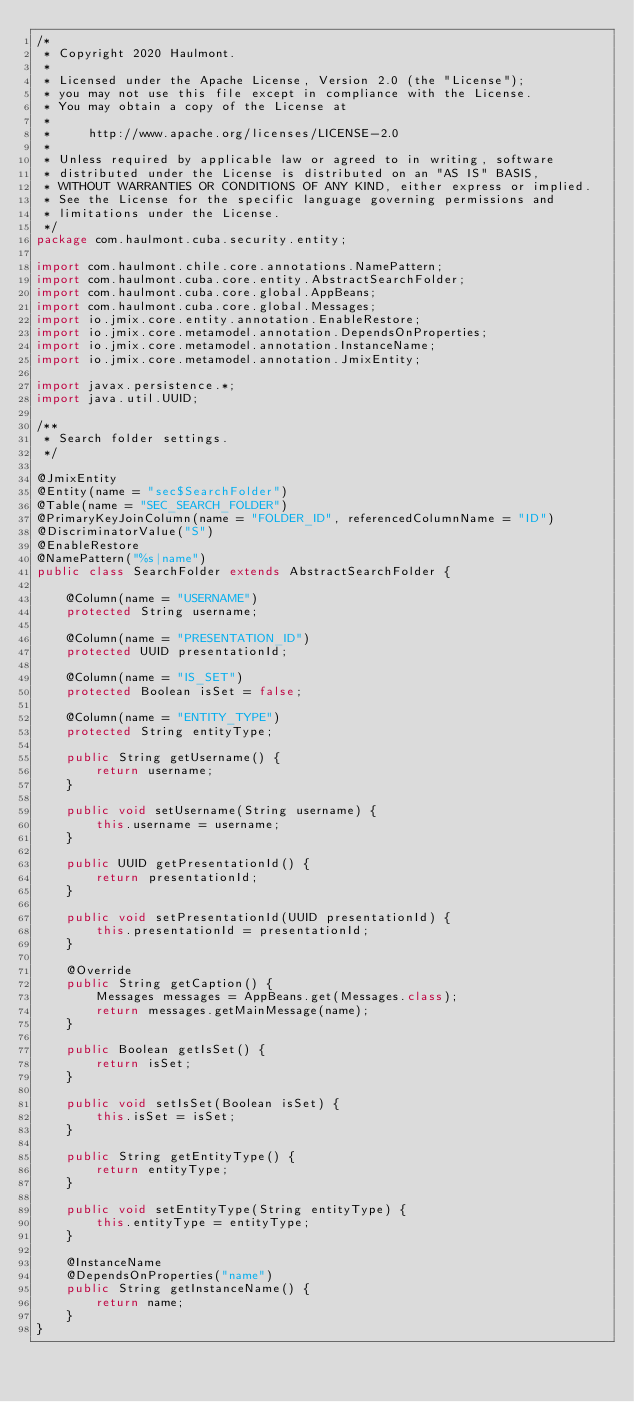Convert code to text. <code><loc_0><loc_0><loc_500><loc_500><_Java_>/*
 * Copyright 2020 Haulmont.
 *
 * Licensed under the Apache License, Version 2.0 (the "License");
 * you may not use this file except in compliance with the License.
 * You may obtain a copy of the License at
 *
 *     http://www.apache.org/licenses/LICENSE-2.0
 *
 * Unless required by applicable law or agreed to in writing, software
 * distributed under the License is distributed on an "AS IS" BASIS,
 * WITHOUT WARRANTIES OR CONDITIONS OF ANY KIND, either express or implied.
 * See the License for the specific language governing permissions and
 * limitations under the License.
 */
package com.haulmont.cuba.security.entity;

import com.haulmont.chile.core.annotations.NamePattern;
import com.haulmont.cuba.core.entity.AbstractSearchFolder;
import com.haulmont.cuba.core.global.AppBeans;
import com.haulmont.cuba.core.global.Messages;
import io.jmix.core.entity.annotation.EnableRestore;
import io.jmix.core.metamodel.annotation.DependsOnProperties;
import io.jmix.core.metamodel.annotation.InstanceName;
import io.jmix.core.metamodel.annotation.JmixEntity;

import javax.persistence.*;
import java.util.UUID;

/**
 * Search folder settings.
 */

@JmixEntity
@Entity(name = "sec$SearchFolder")
@Table(name = "SEC_SEARCH_FOLDER")
@PrimaryKeyJoinColumn(name = "FOLDER_ID", referencedColumnName = "ID")
@DiscriminatorValue("S")
@EnableRestore
@NamePattern("%s|name")
public class SearchFolder extends AbstractSearchFolder {

    @Column(name = "USERNAME")
    protected String username;

    @Column(name = "PRESENTATION_ID")
    protected UUID presentationId;

    @Column(name = "IS_SET")
    protected Boolean isSet = false;

    @Column(name = "ENTITY_TYPE")
    protected String entityType;

    public String getUsername() {
        return username;
    }

    public void setUsername(String username) {
        this.username = username;
    }

    public UUID getPresentationId() {
        return presentationId;
    }

    public void setPresentationId(UUID presentationId) {
        this.presentationId = presentationId;
    }

    @Override
    public String getCaption() {
        Messages messages = AppBeans.get(Messages.class);
        return messages.getMainMessage(name);
    }

    public Boolean getIsSet() {
        return isSet;
    }

    public void setIsSet(Boolean isSet) {
        this.isSet = isSet;
    }

    public String getEntityType() {
        return entityType;
    }

    public void setEntityType(String entityType) {
        this.entityType = entityType;
    }

    @InstanceName
    @DependsOnProperties("name")
    public String getInstanceName() {
        return name;
    }
}
</code> 